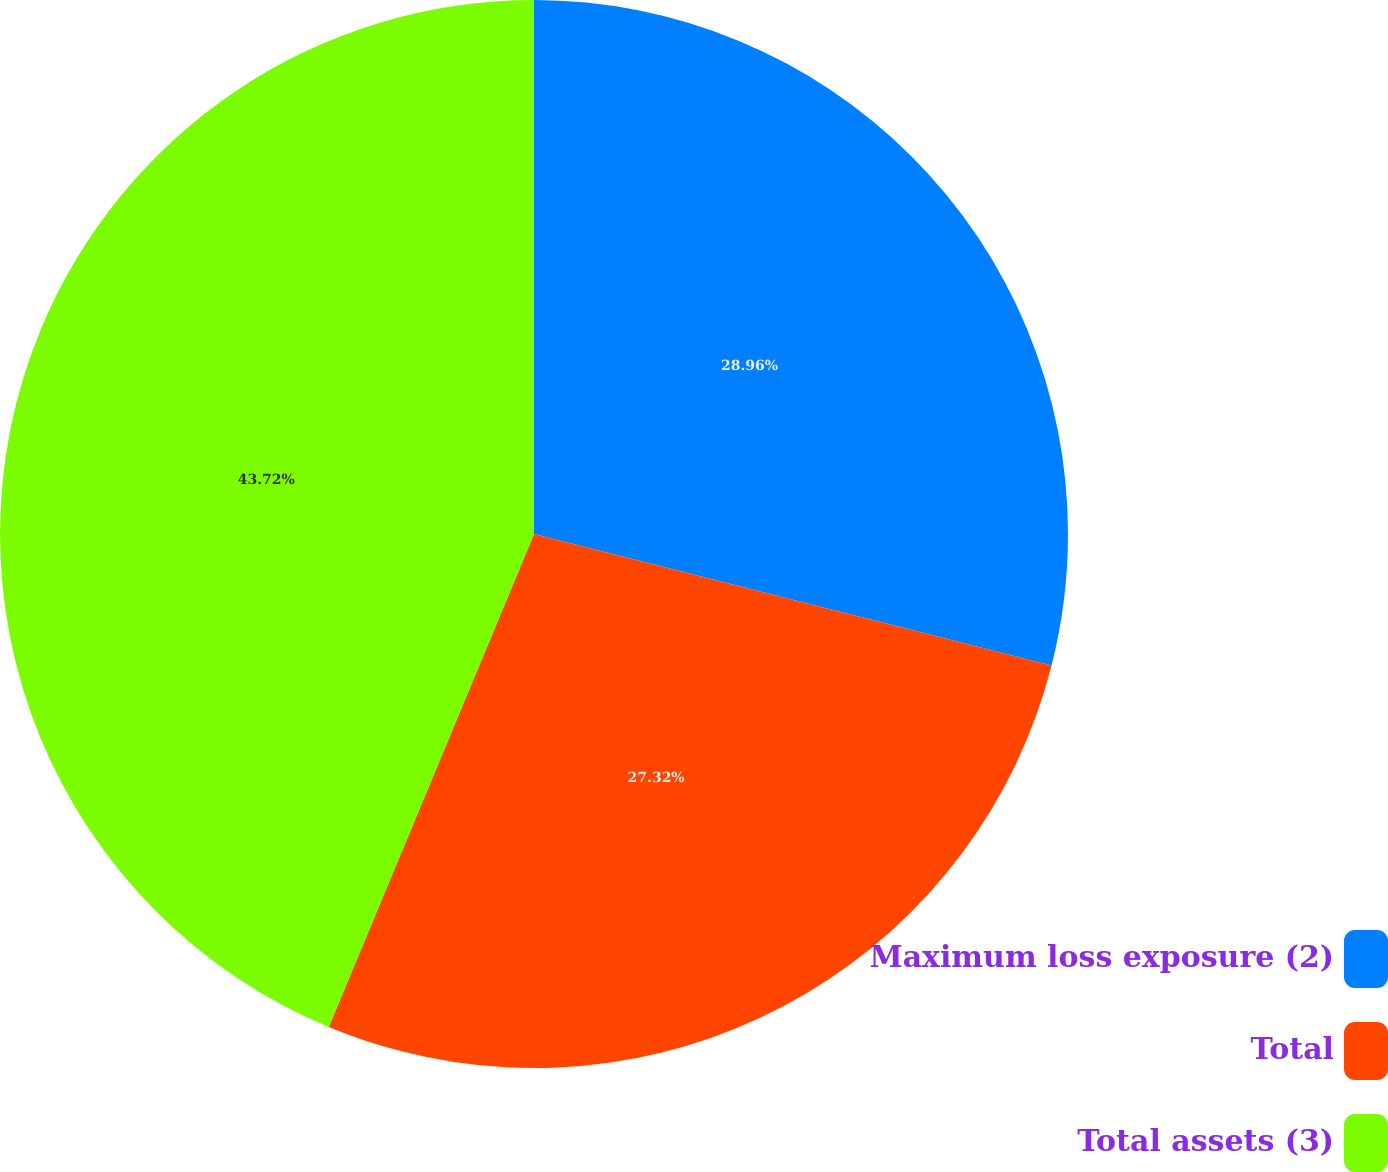<chart> <loc_0><loc_0><loc_500><loc_500><pie_chart><fcel>Maximum loss exposure (2)<fcel>Total<fcel>Total assets (3)<nl><fcel>28.96%<fcel>27.32%<fcel>43.72%<nl></chart> 